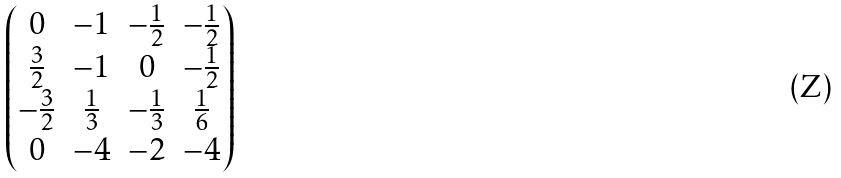<formula> <loc_0><loc_0><loc_500><loc_500>\begin{pmatrix} 0 & - 1 & - \frac { 1 } { 2 } & - \frac { 1 } { 2 } \\ \frac { 3 } { 2 } & - 1 & 0 & - \frac { 1 } { 2 } \\ - \frac { 3 } { 2 } & \frac { 1 } { 3 } & - \frac { 1 } { 3 } & \frac { 1 } { 6 } \\ 0 & - 4 & - 2 & - 4 \end{pmatrix}</formula> 